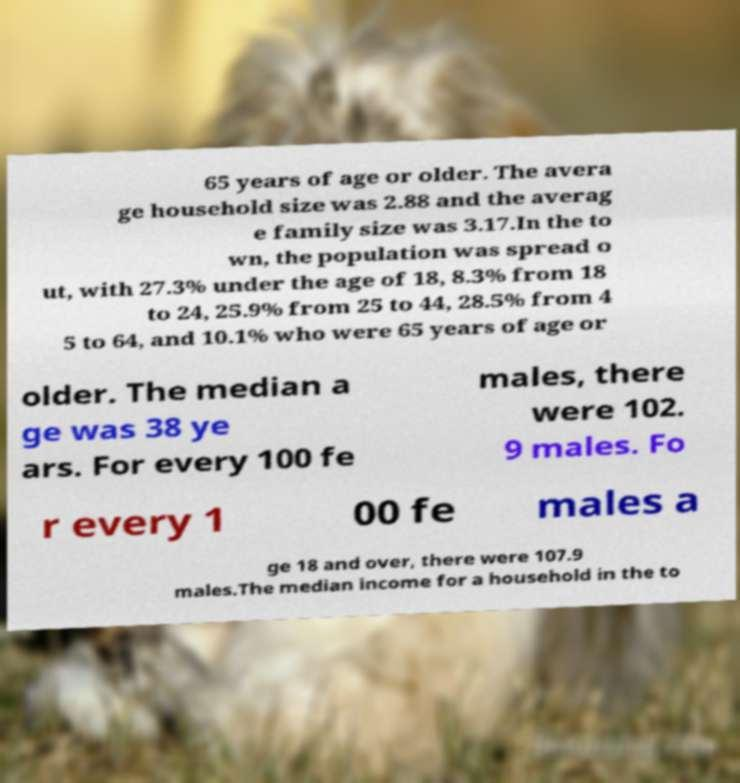There's text embedded in this image that I need extracted. Can you transcribe it verbatim? 65 years of age or older. The avera ge household size was 2.88 and the averag e family size was 3.17.In the to wn, the population was spread o ut, with 27.3% under the age of 18, 8.3% from 18 to 24, 25.9% from 25 to 44, 28.5% from 4 5 to 64, and 10.1% who were 65 years of age or older. The median a ge was 38 ye ars. For every 100 fe males, there were 102. 9 males. Fo r every 1 00 fe males a ge 18 and over, there were 107.9 males.The median income for a household in the to 